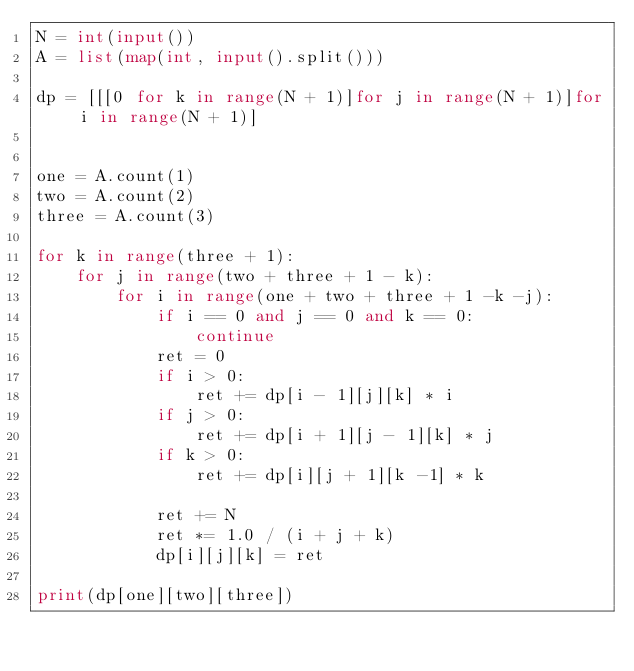<code> <loc_0><loc_0><loc_500><loc_500><_Python_>N = int(input())
A = list(map(int, input().split()))

dp = [[[0 for k in range(N + 1)]for j in range(N + 1)]for i in range(N + 1)]


one = A.count(1)
two = A.count(2)
three = A.count(3)

for k in range(three + 1):
    for j in range(two + three + 1 - k):
        for i in range(one + two + three + 1 -k -j):
            if i == 0 and j == 0 and k == 0:
                continue
            ret = 0
            if i > 0:
                ret += dp[i - 1][j][k] * i
            if j > 0:
                ret += dp[i + 1][j - 1][k] * j 
            if k > 0:
                ret += dp[i][j + 1][k -1] * k

            ret += N
            ret *= 1.0 / (i + j + k)
            dp[i][j][k] = ret

print(dp[one][two][three])

</code> 